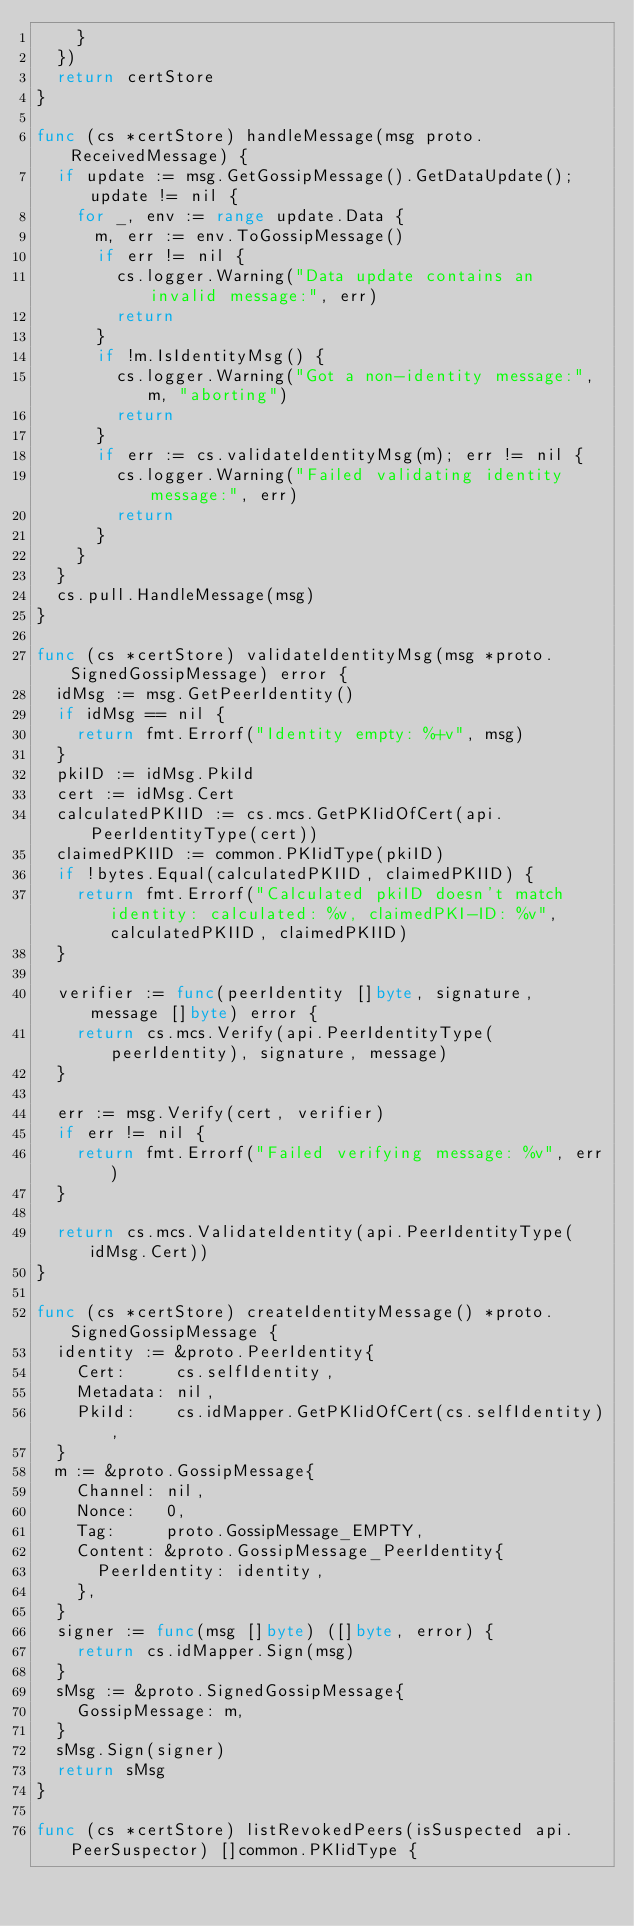<code> <loc_0><loc_0><loc_500><loc_500><_Go_>		}
	})
	return certStore
}

func (cs *certStore) handleMessage(msg proto.ReceivedMessage) {
	if update := msg.GetGossipMessage().GetDataUpdate(); update != nil {
		for _, env := range update.Data {
			m, err := env.ToGossipMessage()
			if err != nil {
				cs.logger.Warning("Data update contains an invalid message:", err)
				return
			}
			if !m.IsIdentityMsg() {
				cs.logger.Warning("Got a non-identity message:", m, "aborting")
				return
			}
			if err := cs.validateIdentityMsg(m); err != nil {
				cs.logger.Warning("Failed validating identity message:", err)
				return
			}
		}
	}
	cs.pull.HandleMessage(msg)
}

func (cs *certStore) validateIdentityMsg(msg *proto.SignedGossipMessage) error {
	idMsg := msg.GetPeerIdentity()
	if idMsg == nil {
		return fmt.Errorf("Identity empty: %+v", msg)
	}
	pkiID := idMsg.PkiId
	cert := idMsg.Cert
	calculatedPKIID := cs.mcs.GetPKIidOfCert(api.PeerIdentityType(cert))
	claimedPKIID := common.PKIidType(pkiID)
	if !bytes.Equal(calculatedPKIID, claimedPKIID) {
		return fmt.Errorf("Calculated pkiID doesn't match identity: calculated: %v, claimedPKI-ID: %v", calculatedPKIID, claimedPKIID)
	}

	verifier := func(peerIdentity []byte, signature, message []byte) error {
		return cs.mcs.Verify(api.PeerIdentityType(peerIdentity), signature, message)
	}

	err := msg.Verify(cert, verifier)
	if err != nil {
		return fmt.Errorf("Failed verifying message: %v", err)
	}

	return cs.mcs.ValidateIdentity(api.PeerIdentityType(idMsg.Cert))
}

func (cs *certStore) createIdentityMessage() *proto.SignedGossipMessage {
	identity := &proto.PeerIdentity{
		Cert:     cs.selfIdentity,
		Metadata: nil,
		PkiId:    cs.idMapper.GetPKIidOfCert(cs.selfIdentity),
	}
	m := &proto.GossipMessage{
		Channel: nil,
		Nonce:   0,
		Tag:     proto.GossipMessage_EMPTY,
		Content: &proto.GossipMessage_PeerIdentity{
			PeerIdentity: identity,
		},
	}
	signer := func(msg []byte) ([]byte, error) {
		return cs.idMapper.Sign(msg)
	}
	sMsg := &proto.SignedGossipMessage{
		GossipMessage: m,
	}
	sMsg.Sign(signer)
	return sMsg
}

func (cs *certStore) listRevokedPeers(isSuspected api.PeerSuspector) []common.PKIidType {</code> 